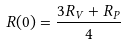<formula> <loc_0><loc_0><loc_500><loc_500>R ( 0 ) = \frac { 3 R _ { V } + R _ { P } } { 4 }</formula> 